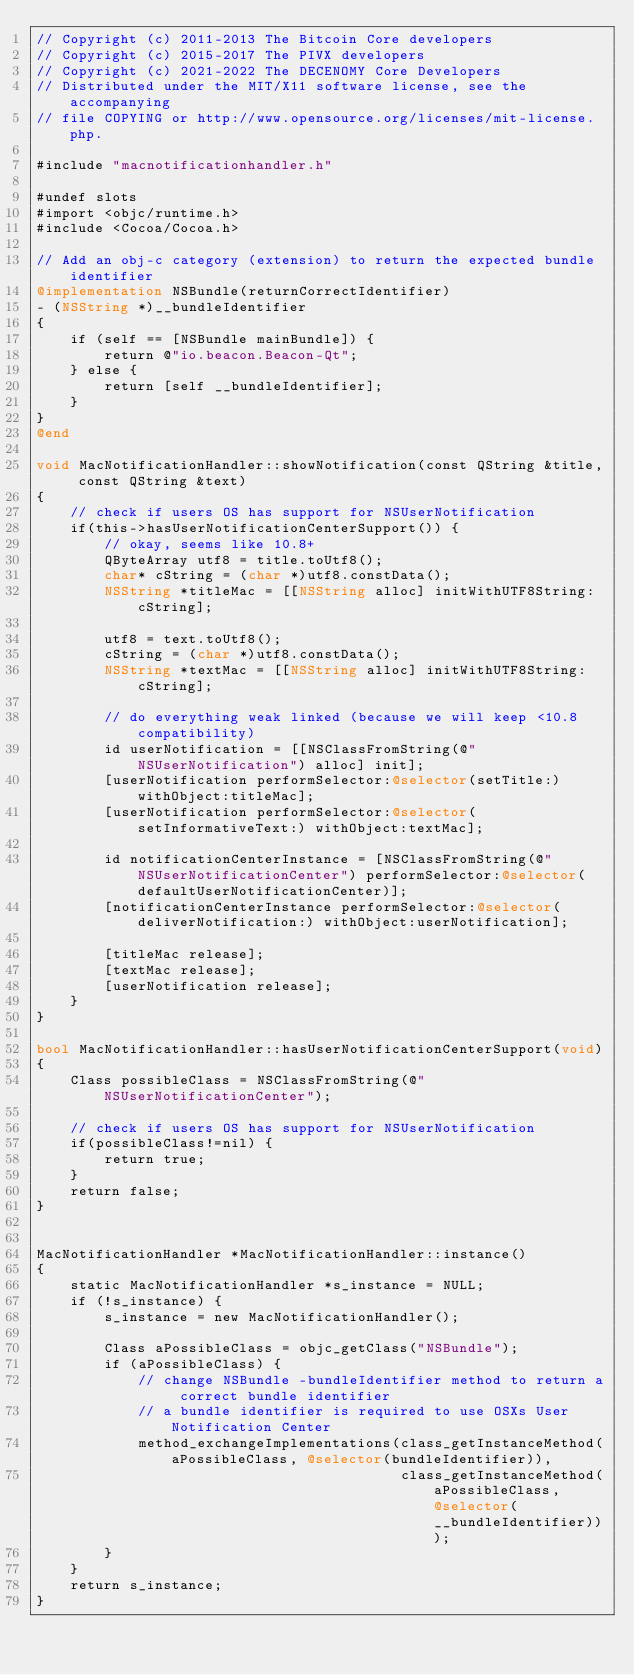<code> <loc_0><loc_0><loc_500><loc_500><_ObjectiveC_>// Copyright (c) 2011-2013 The Bitcoin Core developers
// Copyright (c) 2015-2017 The PIVX developers
// Copyright (c) 2021-2022 The DECENOMY Core Developers
// Distributed under the MIT/X11 software license, see the accompanying
// file COPYING or http://www.opensource.org/licenses/mit-license.php.

#include "macnotificationhandler.h"

#undef slots
#import <objc/runtime.h>
#include <Cocoa/Cocoa.h>

// Add an obj-c category (extension) to return the expected bundle identifier
@implementation NSBundle(returnCorrectIdentifier)
- (NSString *)__bundleIdentifier
{
    if (self == [NSBundle mainBundle]) {
        return @"io.beacon.Beacon-Qt";
    } else {
        return [self __bundleIdentifier];
    }
}
@end

void MacNotificationHandler::showNotification(const QString &title, const QString &text)
{
    // check if users OS has support for NSUserNotification
    if(this->hasUserNotificationCenterSupport()) {
        // okay, seems like 10.8+
        QByteArray utf8 = title.toUtf8();
        char* cString = (char *)utf8.constData();
        NSString *titleMac = [[NSString alloc] initWithUTF8String:cString];

        utf8 = text.toUtf8();
        cString = (char *)utf8.constData();
        NSString *textMac = [[NSString alloc] initWithUTF8String:cString];

        // do everything weak linked (because we will keep <10.8 compatibility)
        id userNotification = [[NSClassFromString(@"NSUserNotification") alloc] init];
        [userNotification performSelector:@selector(setTitle:) withObject:titleMac];
        [userNotification performSelector:@selector(setInformativeText:) withObject:textMac];

        id notificationCenterInstance = [NSClassFromString(@"NSUserNotificationCenter") performSelector:@selector(defaultUserNotificationCenter)];
        [notificationCenterInstance performSelector:@selector(deliverNotification:) withObject:userNotification];

        [titleMac release];
        [textMac release];
        [userNotification release];
    }
}

bool MacNotificationHandler::hasUserNotificationCenterSupport(void)
{
    Class possibleClass = NSClassFromString(@"NSUserNotificationCenter");

    // check if users OS has support for NSUserNotification
    if(possibleClass!=nil) {
        return true;
    }
    return false;
}


MacNotificationHandler *MacNotificationHandler::instance()
{
    static MacNotificationHandler *s_instance = NULL;
    if (!s_instance) {
        s_instance = new MacNotificationHandler();
        
        Class aPossibleClass = objc_getClass("NSBundle");
        if (aPossibleClass) {
            // change NSBundle -bundleIdentifier method to return a correct bundle identifier
            // a bundle identifier is required to use OSXs User Notification Center
            method_exchangeImplementations(class_getInstanceMethod(aPossibleClass, @selector(bundleIdentifier)),
                                           class_getInstanceMethod(aPossibleClass, @selector(__bundleIdentifier)));
        }
    }
    return s_instance;
}
</code> 